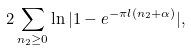<formula> <loc_0><loc_0><loc_500><loc_500>2 \sum _ { n _ { 2 } \geq 0 } \ln | 1 - e ^ { - \pi l ( n _ { 2 } + \alpha ) } | ,</formula> 